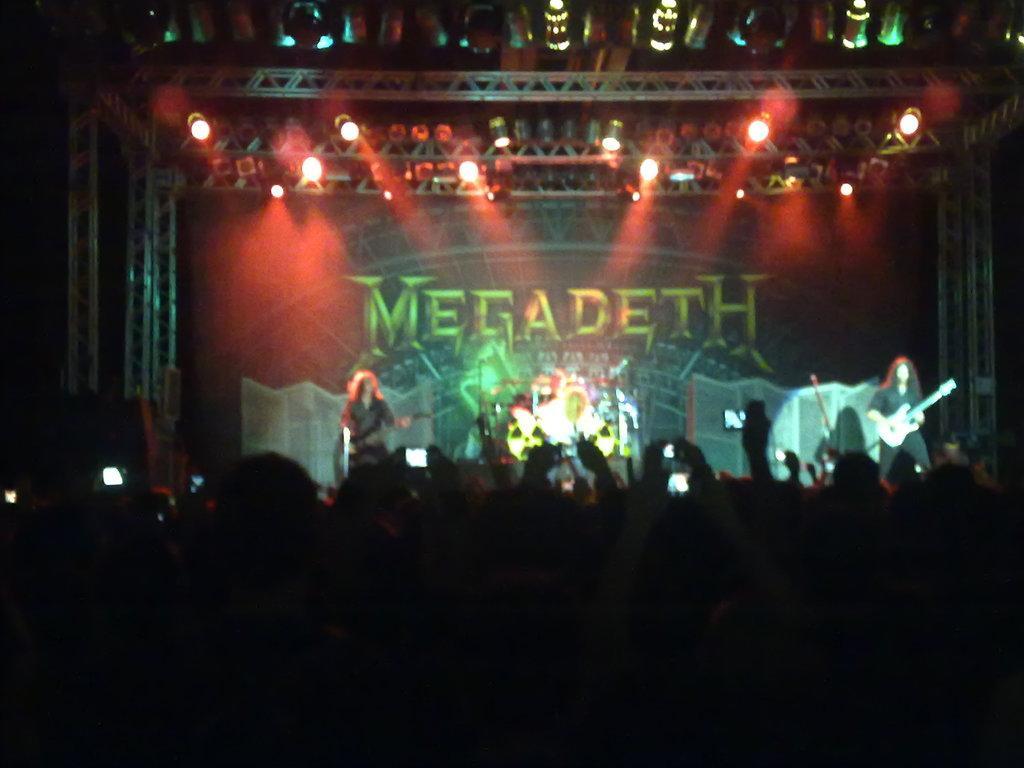How would you summarize this image in a sentence or two? Few people are performing on the stage, these are the focused lights at the top of an image. 